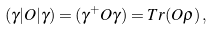Convert formula to latex. <formula><loc_0><loc_0><loc_500><loc_500>( \gamma | O | \gamma ) = ( \gamma ^ { + } O \gamma ) = T r ( O \rho ) \, ,</formula> 